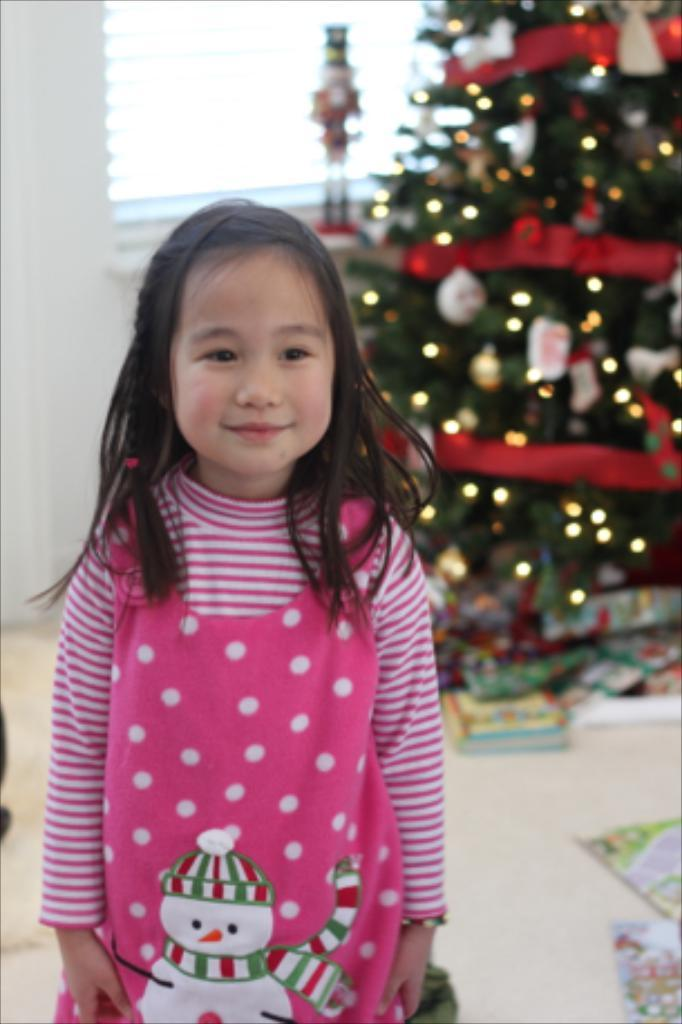What is the expression on the girl's face in the image? The girl is smiling in the image. What can be seen in the background of the image? There is a Christmas tree and a window in the background. What object is placed in front of the Christmas tree? There is a book in front of the Christmas tree. How many apples are on the girl's head in the image? There are no apples present in the image. Is the girl holding any money in the image? There is no indication of money in the image. 